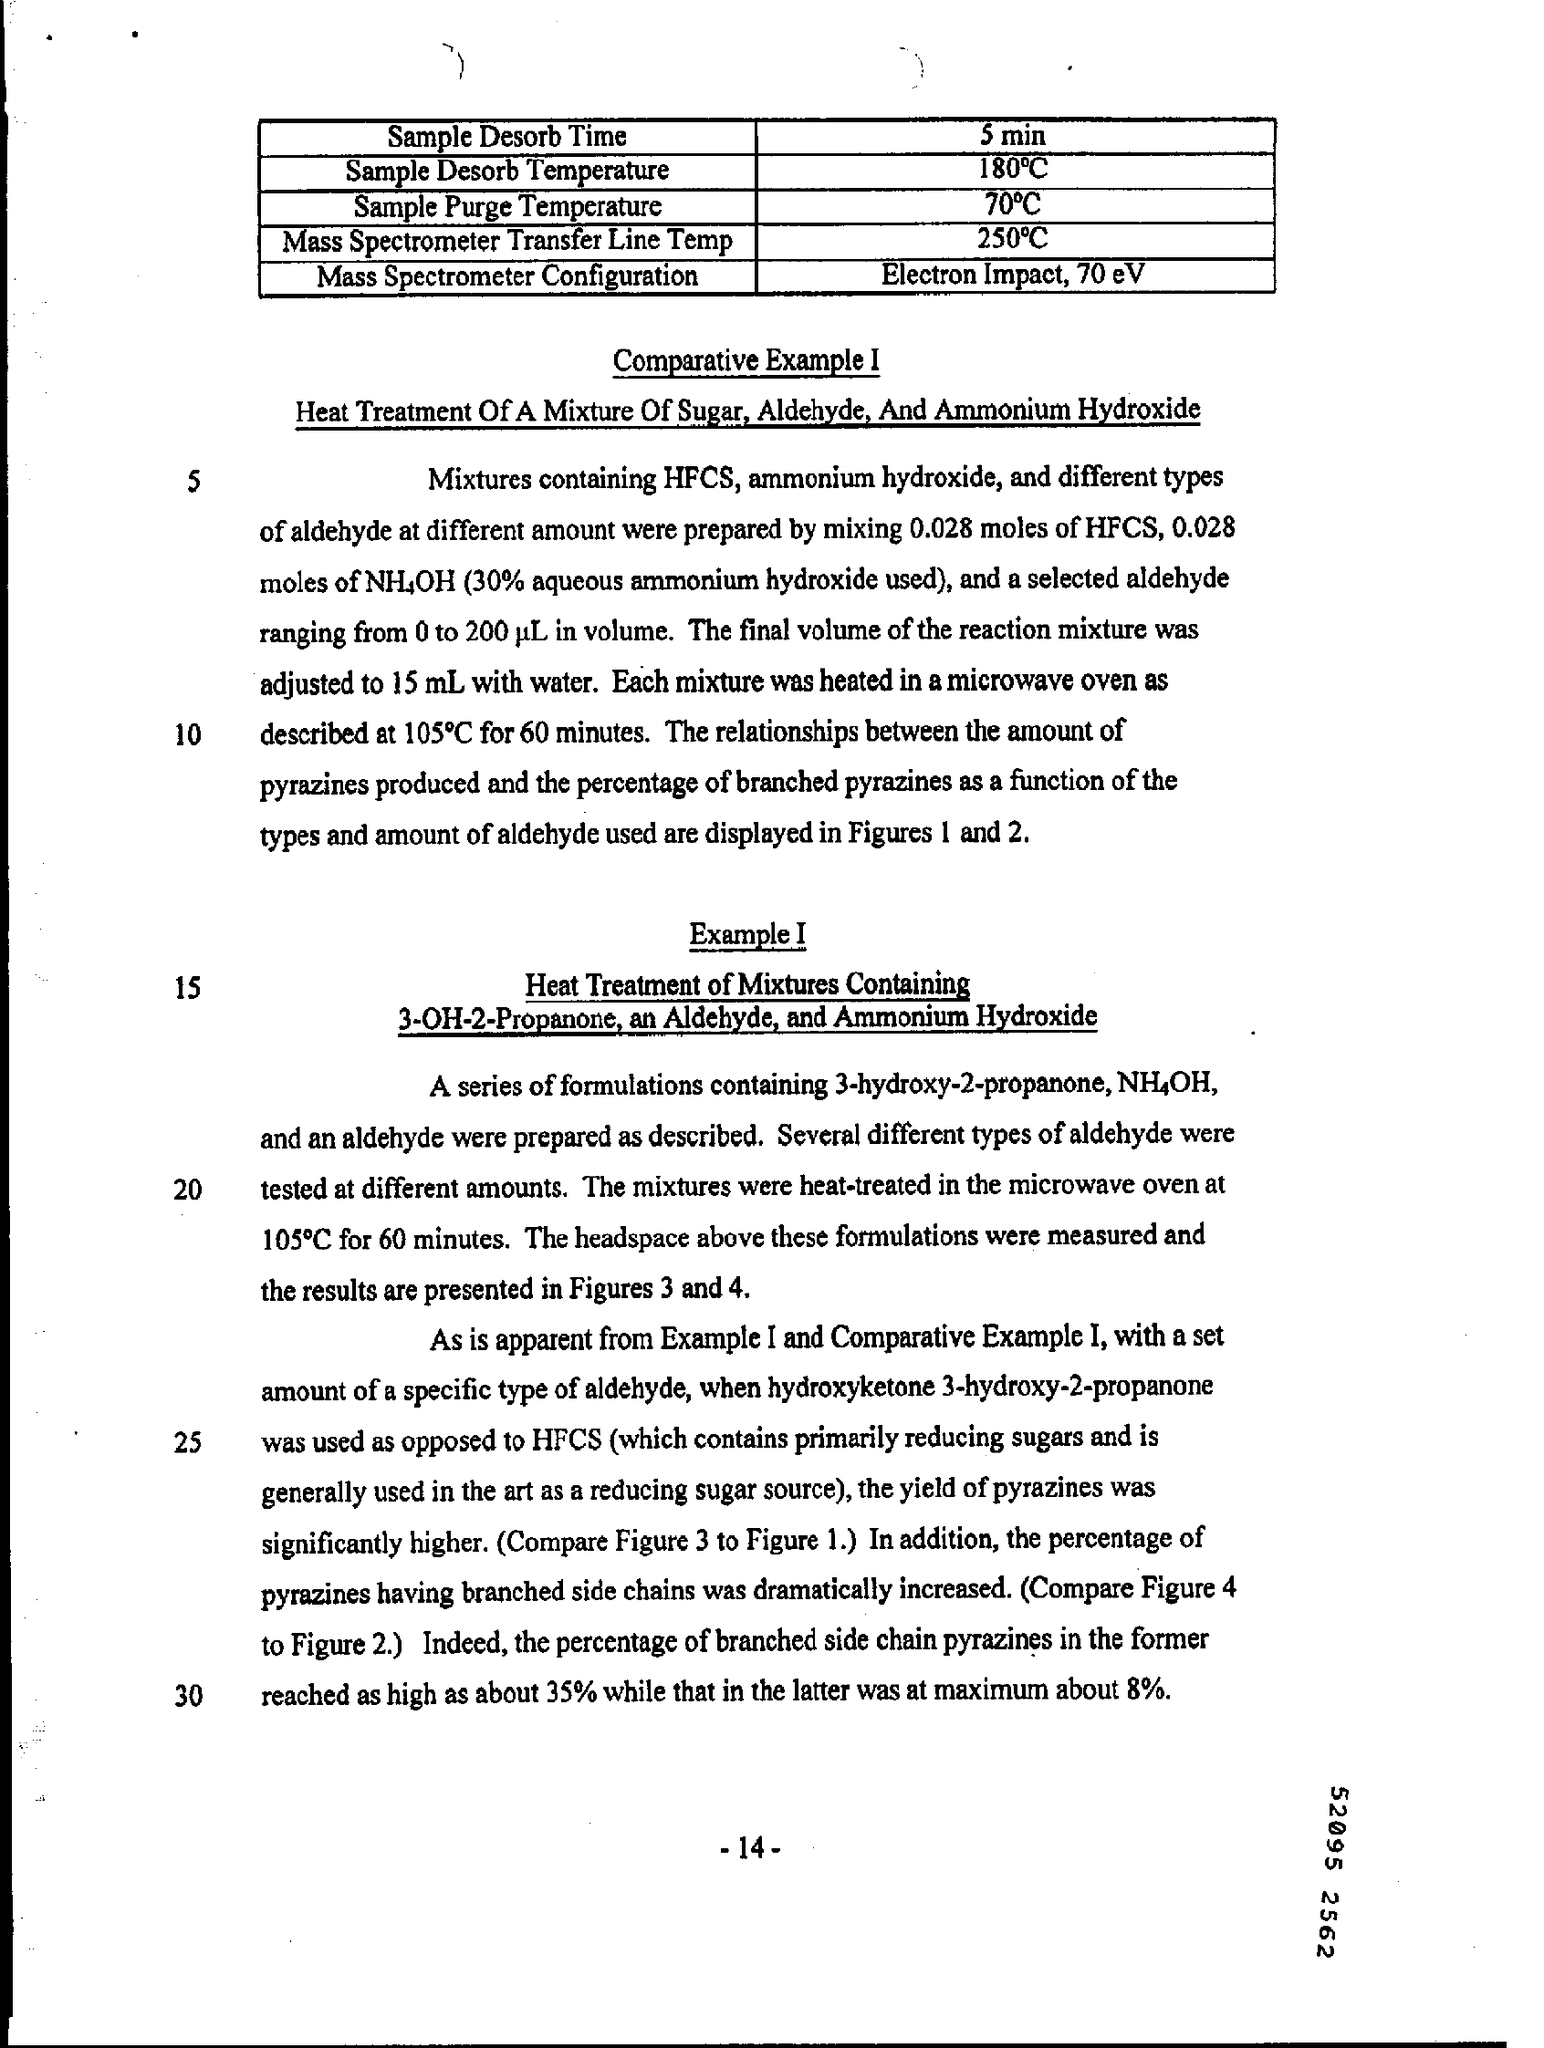Specify some key components in this picture. The page number mentioned in this document is -14-. The mass spectrometer configuration mentioned in the document is electron impact at 70 eV. The sample desorb time is 5 minutes, according to the document. 